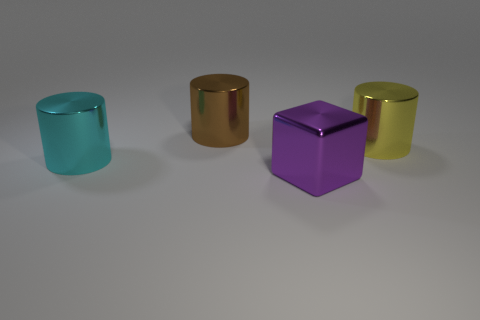Is the cyan metallic cylinder the same size as the yellow thing?
Offer a terse response. Yes. How many cylinders are either brown objects or big cyan objects?
Offer a terse response. 2. What number of big brown metallic objects have the same shape as the yellow thing?
Your response must be concise. 1. Is the number of blocks that are to the right of the yellow metal cylinder greater than the number of large purple metal objects that are behind the large cyan metal thing?
Keep it short and to the point. No. There is a brown thing that is the same size as the yellow object; what material is it?
Offer a terse response. Metal. There is a metallic cylinder on the right side of the purple object; what color is it?
Your answer should be very brief. Yellow. What number of small blue rubber blocks are there?
Provide a succinct answer. 0. There is a metallic cylinder left of the large metallic cylinder that is behind the yellow cylinder; are there any large metal blocks that are on the left side of it?
Give a very brief answer. No. There is a purple object that is the same size as the brown cylinder; what shape is it?
Ensure brevity in your answer.  Cube. What shape is the big object that is behind the large cylinder right of the brown metal cylinder?
Make the answer very short. Cylinder. 